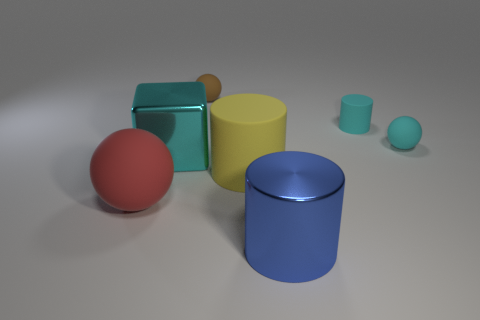Subtract all yellow matte cylinders. How many cylinders are left? 2 Subtract all blue cylinders. How many cylinders are left? 2 Subtract 1 balls. How many balls are left? 2 Subtract all cubes. How many objects are left? 6 Subtract all brown spheres. Subtract all purple blocks. How many spheres are left? 2 Add 6 yellow rubber objects. How many yellow rubber objects are left? 7 Add 1 green metal spheres. How many green metal spheres exist? 1 Add 1 small cyan matte balls. How many objects exist? 8 Subtract 1 cyan spheres. How many objects are left? 6 Subtract all gray spheres. How many gray cylinders are left? 0 